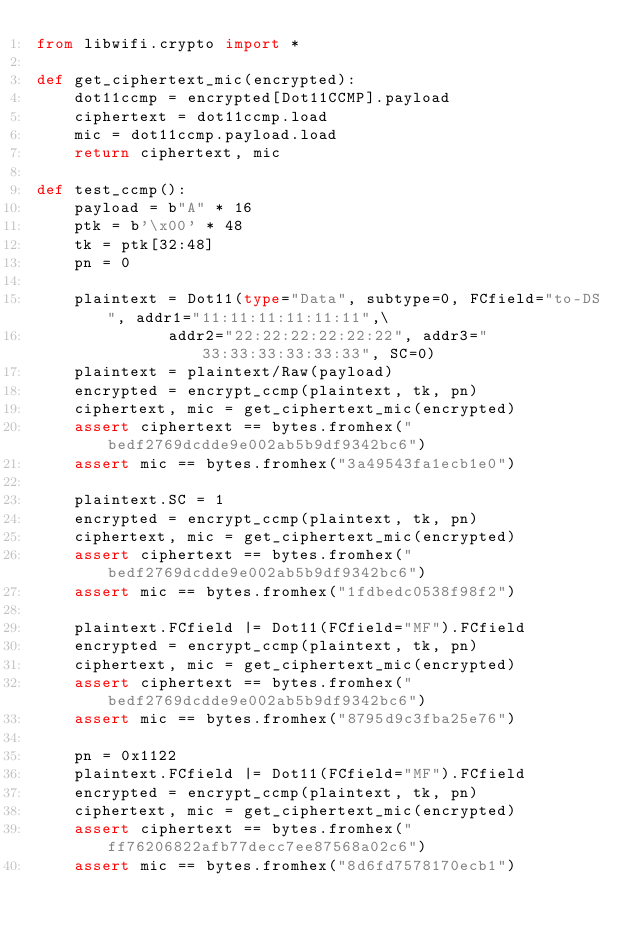Convert code to text. <code><loc_0><loc_0><loc_500><loc_500><_Python_>from libwifi.crypto import *

def get_ciphertext_mic(encrypted):
	dot11ccmp = encrypted[Dot11CCMP].payload
	ciphertext = dot11ccmp.load
	mic = dot11ccmp.payload.load
	return ciphertext, mic

def test_ccmp():
	payload = b"A" * 16
	ptk = b'\x00' * 48
	tk = ptk[32:48]
	pn = 0

	plaintext = Dot11(type="Data", subtype=0, FCfield="to-DS", addr1="11:11:11:11:11:11",\
			  addr2="22:22:22:22:22:22", addr3="33:33:33:33:33:33", SC=0)
	plaintext = plaintext/Raw(payload)
	encrypted = encrypt_ccmp(plaintext, tk, pn)
	ciphertext, mic = get_ciphertext_mic(encrypted)
	assert ciphertext == bytes.fromhex("bedf2769dcdde9e002ab5b9df9342bc6")
	assert mic == bytes.fromhex("3a49543fa1ecb1e0")

	plaintext.SC = 1
	encrypted = encrypt_ccmp(plaintext, tk, pn)
	ciphertext, mic = get_ciphertext_mic(encrypted)
	assert ciphertext == bytes.fromhex("bedf2769dcdde9e002ab5b9df9342bc6")
	assert mic == bytes.fromhex("1fdbedc0538f98f2")

	plaintext.FCfield |= Dot11(FCfield="MF").FCfield
	encrypted = encrypt_ccmp(plaintext, tk, pn)
	ciphertext, mic = get_ciphertext_mic(encrypted)
	assert ciphertext == bytes.fromhex("bedf2769dcdde9e002ab5b9df9342bc6")
	assert mic == bytes.fromhex("8795d9c3fba25e76")

	pn = 0x1122
	plaintext.FCfield |= Dot11(FCfield="MF").FCfield
	encrypted = encrypt_ccmp(plaintext, tk, pn)
	ciphertext, mic = get_ciphertext_mic(encrypted)
	assert ciphertext == bytes.fromhex("ff76206822afb77decc7ee87568a02c6")
	assert mic == bytes.fromhex("8d6fd7578170ecb1")

</code> 